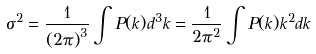Convert formula to latex. <formula><loc_0><loc_0><loc_500><loc_500>\sigma ^ { 2 } = \frac { 1 } { \left ( 2 \pi \right ) ^ { 3 } } \int P ( k ) d ^ { 3 } k = \frac { 1 } { 2 \pi ^ { 2 } } \int P ( k ) k ^ { 2 } d k</formula> 